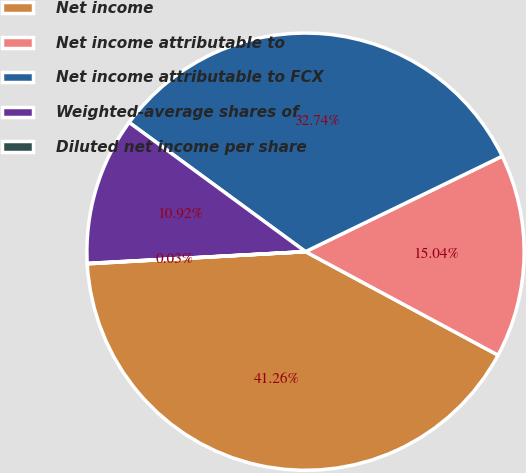Convert chart to OTSL. <chart><loc_0><loc_0><loc_500><loc_500><pie_chart><fcel>Net income<fcel>Net income attributable to<fcel>Net income attributable to FCX<fcel>Weighted-average shares of<fcel>Diluted net income per share<nl><fcel>41.26%<fcel>15.04%<fcel>32.74%<fcel>10.92%<fcel>0.03%<nl></chart> 